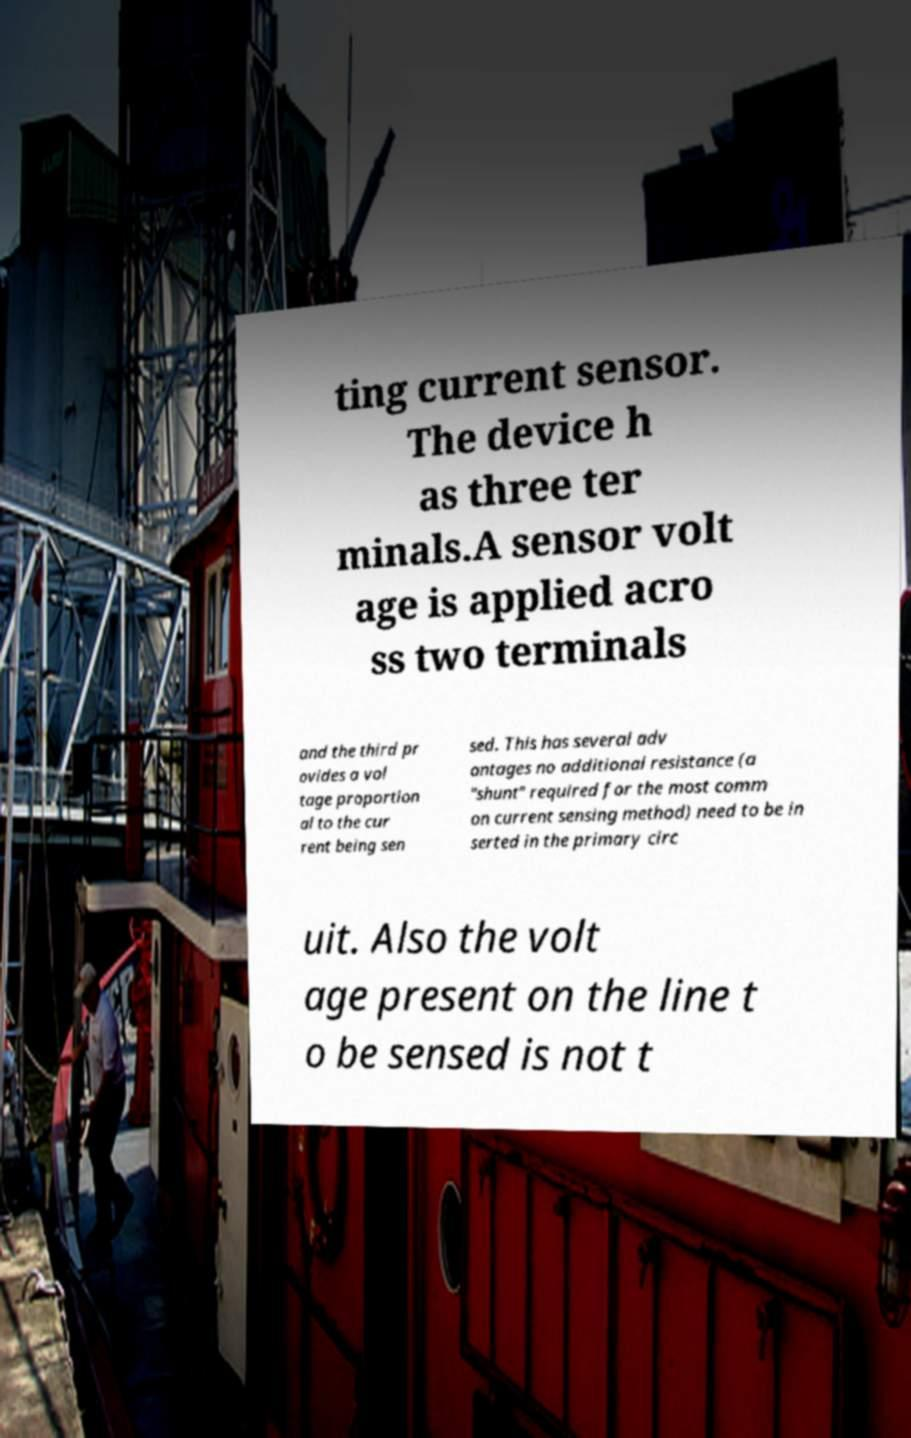Could you assist in decoding the text presented in this image and type it out clearly? ting current sensor. The device h as three ter minals.A sensor volt age is applied acro ss two terminals and the third pr ovides a vol tage proportion al to the cur rent being sen sed. This has several adv antages no additional resistance (a "shunt" required for the most comm on current sensing method) need to be in serted in the primary circ uit. Also the volt age present on the line t o be sensed is not t 